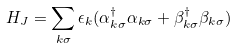Convert formula to latex. <formula><loc_0><loc_0><loc_500><loc_500>H _ { J } = \sum _ { k \sigma } \epsilon _ { k } ( \alpha ^ { \dagger } _ { k \sigma } \alpha _ { k \sigma } + \beta ^ { \dagger } _ { k \sigma } \beta _ { k \sigma } )</formula> 